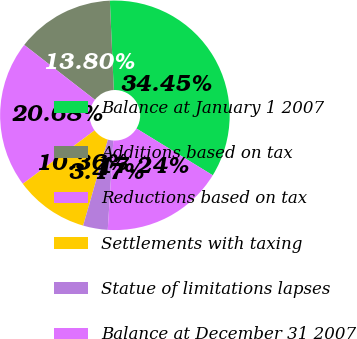<chart> <loc_0><loc_0><loc_500><loc_500><pie_chart><fcel>Balance at January 1 2007<fcel>Additions based on tax<fcel>Reductions based on tax<fcel>Settlements with taxing<fcel>Statue of limitations lapses<fcel>Balance at December 31 2007<nl><fcel>34.45%<fcel>13.8%<fcel>20.68%<fcel>10.36%<fcel>3.47%<fcel>17.24%<nl></chart> 